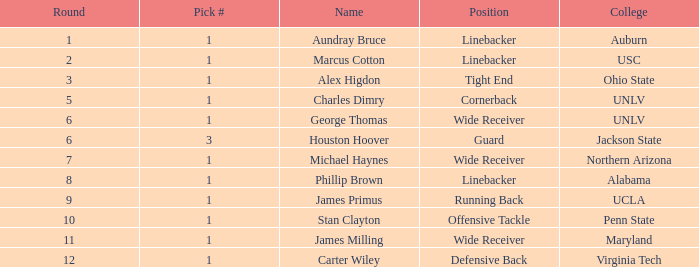In which round was george thomas selected? 6.0. 